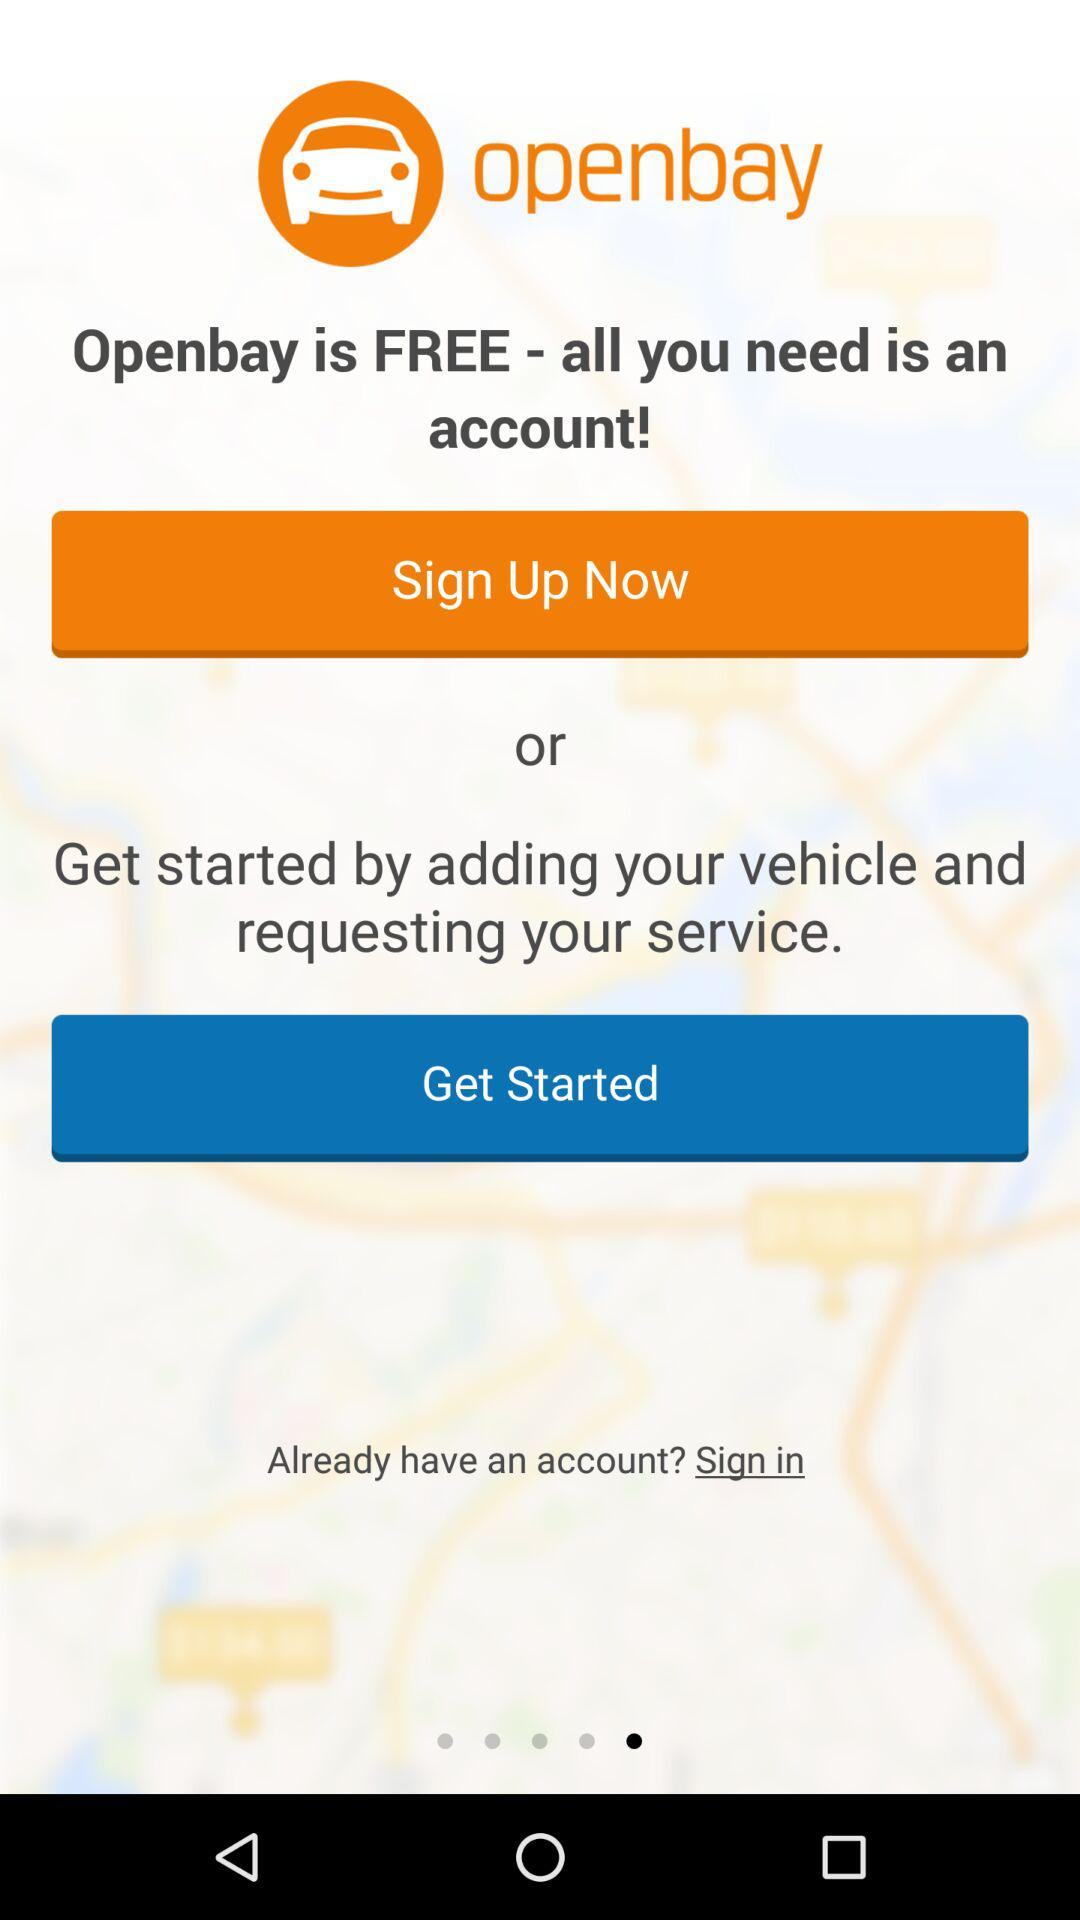Is "Openbay" free or paid?
Answer the question using a single word or phrase. "Openbay" is free. 